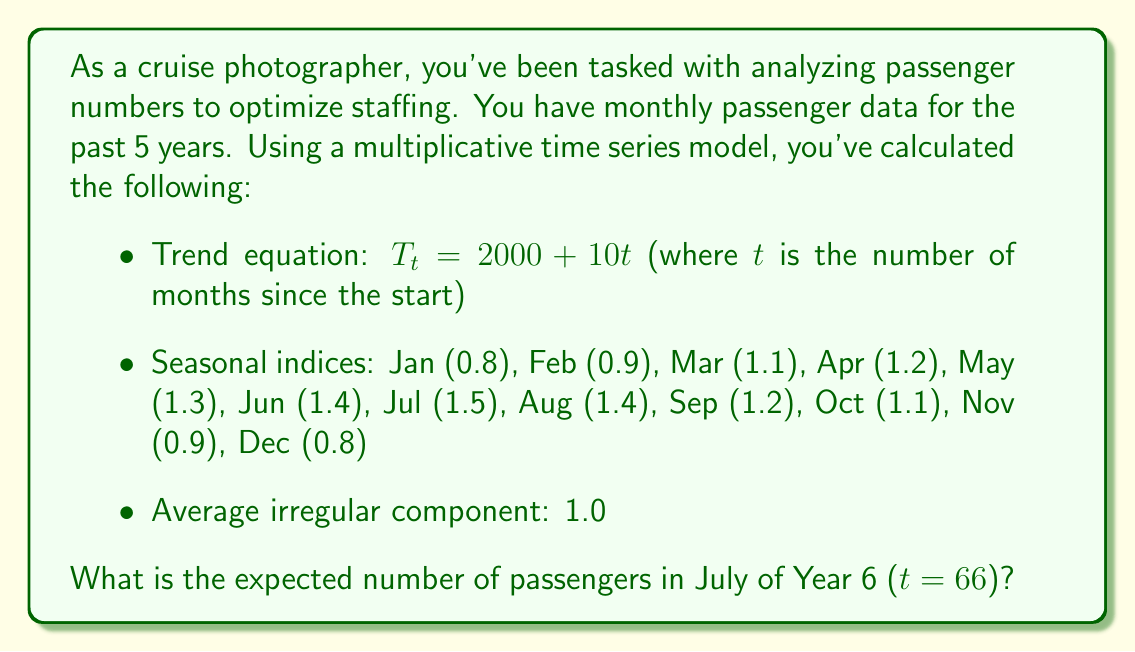Solve this math problem. To solve this problem, we'll use the multiplicative time series model:

$Y_t = T_t \times S_t \times I_t$

Where:
$Y_t$ is the expected number of passengers
$T_t$ is the trend component
$S_t$ is the seasonal component
$I_t$ is the irregular component

Step 1: Calculate the trend component for July of Year 6 (t = 66)
$T_{66} = 2000 + 10(66) = 2660$

Step 2: Identify the seasonal index for July
$S_{July} = 1.5$

Step 3: Use the average irregular component
$I_t = 1.0$

Step 4: Apply the multiplicative model
$Y_{66} = T_{66} \times S_{July} \times I_t$
$Y_{66} = 2660 \times 1.5 \times 1.0$
$Y_{66} = 3990$

Therefore, the expected number of passengers in July of Year 6 is 3,990.
Answer: 3,990 passengers 